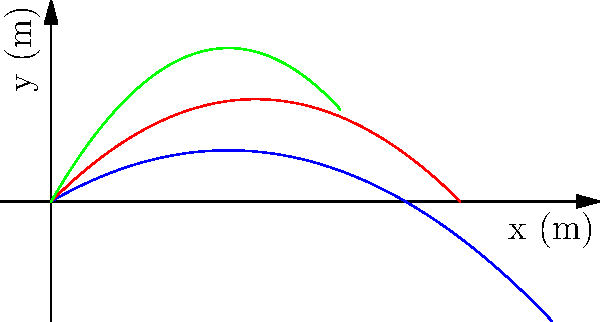In the context of projectile motion, consider three projectiles launched with the same initial velocity of 50 m/s but at different angles: 30°, 45°, and 60°. Based on the trajectories shown in the graph, which angle results in the maximum horizontal range? Explain the physical principles behind this phenomenon and how it relates to the study of ballistics in historical warfare. To answer this question, let's analyze the projectile motion step-by-step:

1. The horizontal range of a projectile is given by the equation:
   $$R = \frac{v_0^2 \sin(2\theta)}{g}$$
   where $v_0$ is the initial velocity, $\theta$ is the launch angle, and $g$ is the acceleration due to gravity.

2. To find the maximum range, we need to maximize $\sin(2\theta)$:
   - $\sin(2\theta)$ reaches its maximum value of 1 when $2\theta = 90°$
   - This occurs when $\theta = 45°$

3. Comparing the trajectories in the graph:
   - The red curve (45°) reaches the furthest horizontal distance
   - The blue (30°) and green (60°) curves have equal horizontal ranges

4. This symmetry occurs because:
   $$\sin(2(45°+x)) = \sin(2(45°-x))$$
   So, angles equally above and below 45° result in the same range.

5. In historical warfare, understanding this principle was crucial for:
   - Maximizing the range of projectiles like catapult stones or cannon balls
   - Adjusting siege engine angles for different distances
   - Developing ballistic tables for artillery

6. The study of ballistics evolved from these principles, leading to:
   - More accurate predictions of projectile paths
   - Development of long-range artillery and modern rocketry
   - Understanding of air resistance and other factors affecting projectile motion

This phenomenon demonstrates how mathematical principles in physics directly influenced military strategy and technological development throughout history.
Answer: 45° 